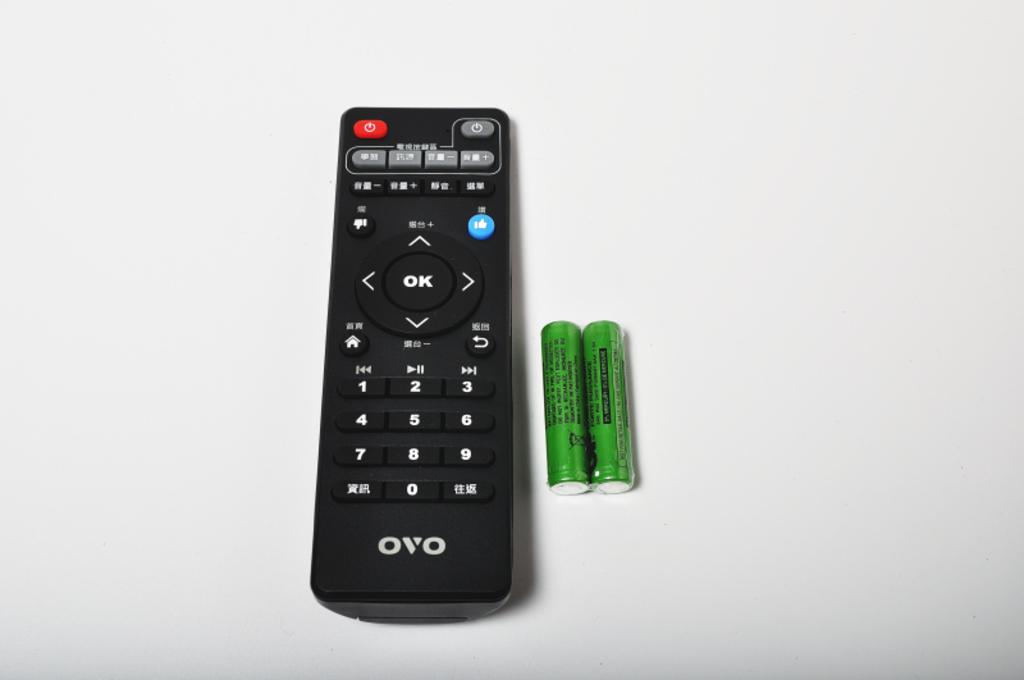What can you select on the middle button?
Make the answer very short. Ok. 